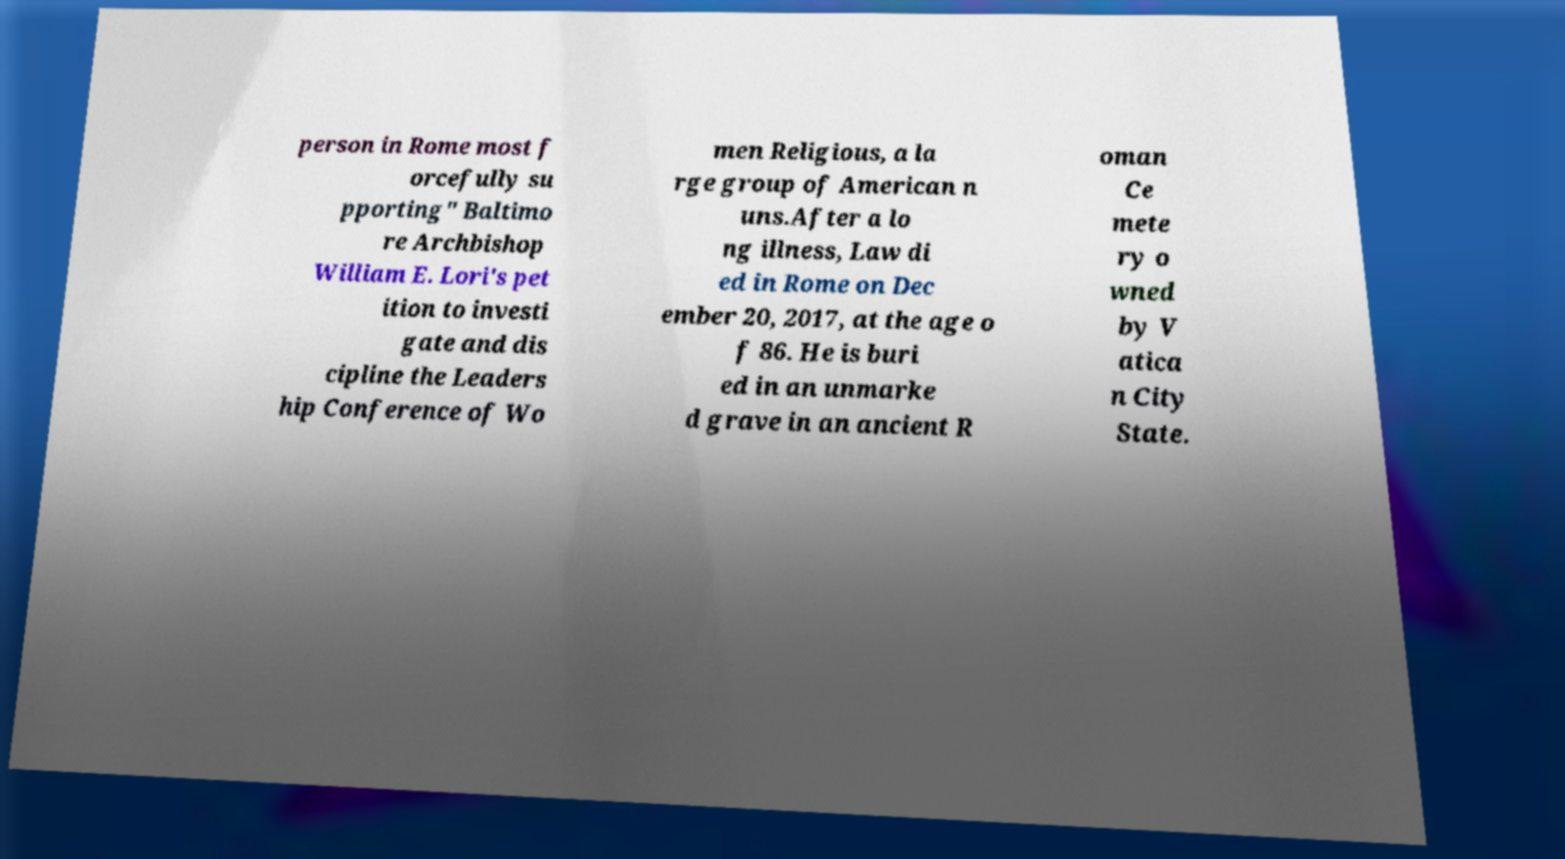I need the written content from this picture converted into text. Can you do that? person in Rome most f orcefully su pporting" Baltimo re Archbishop William E. Lori's pet ition to investi gate and dis cipline the Leaders hip Conference of Wo men Religious, a la rge group of American n uns.After a lo ng illness, Law di ed in Rome on Dec ember 20, 2017, at the age o f 86. He is buri ed in an unmarke d grave in an ancient R oman Ce mete ry o wned by V atica n City State. 